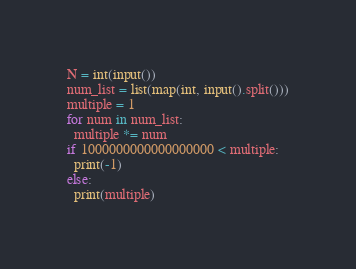Convert code to text. <code><loc_0><loc_0><loc_500><loc_500><_Python_>N = int(input())
num_list = list(map(int, input().split()))
multiple = 1
for num in num_list:
  multiple *= num
if 1000000000000000000 < multiple:
  print(-1)
else:
  print(multiple)</code> 